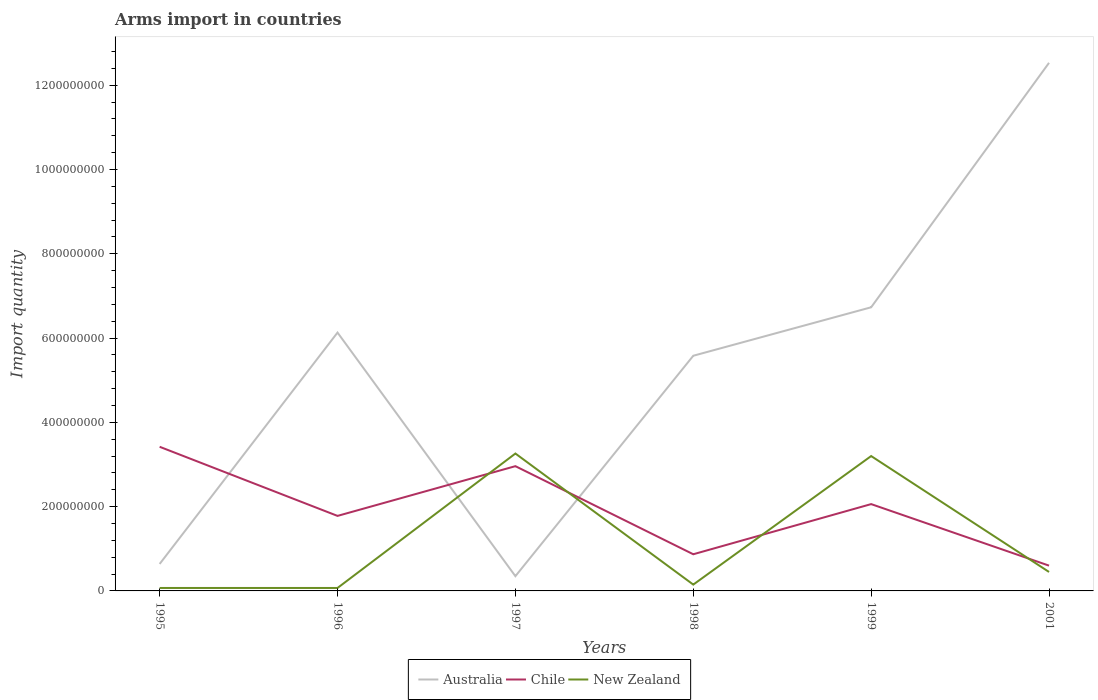How many different coloured lines are there?
Keep it short and to the point. 3. Does the line corresponding to Chile intersect with the line corresponding to New Zealand?
Offer a very short reply. Yes. Across all years, what is the maximum total arms import in Chile?
Make the answer very short. 6.00e+07. In which year was the total arms import in Chile maximum?
Offer a terse response. 2001. What is the total total arms import in Chile in the graph?
Provide a short and direct response. -1.18e+08. What is the difference between the highest and the second highest total arms import in New Zealand?
Make the answer very short. 3.19e+08. Where does the legend appear in the graph?
Make the answer very short. Bottom center. How many legend labels are there?
Give a very brief answer. 3. What is the title of the graph?
Make the answer very short. Arms import in countries. What is the label or title of the Y-axis?
Offer a terse response. Import quantity. What is the Import quantity of Australia in 1995?
Offer a very short reply. 6.40e+07. What is the Import quantity of Chile in 1995?
Provide a succinct answer. 3.42e+08. What is the Import quantity of New Zealand in 1995?
Give a very brief answer. 7.00e+06. What is the Import quantity in Australia in 1996?
Give a very brief answer. 6.13e+08. What is the Import quantity of Chile in 1996?
Your answer should be compact. 1.78e+08. What is the Import quantity of Australia in 1997?
Keep it short and to the point. 3.50e+07. What is the Import quantity in Chile in 1997?
Offer a terse response. 2.96e+08. What is the Import quantity of New Zealand in 1997?
Offer a very short reply. 3.26e+08. What is the Import quantity in Australia in 1998?
Your answer should be compact. 5.58e+08. What is the Import quantity in Chile in 1998?
Keep it short and to the point. 8.70e+07. What is the Import quantity of New Zealand in 1998?
Keep it short and to the point. 1.50e+07. What is the Import quantity in Australia in 1999?
Provide a short and direct response. 6.73e+08. What is the Import quantity of Chile in 1999?
Provide a succinct answer. 2.06e+08. What is the Import quantity of New Zealand in 1999?
Offer a very short reply. 3.20e+08. What is the Import quantity in Australia in 2001?
Provide a short and direct response. 1.25e+09. What is the Import quantity of Chile in 2001?
Provide a succinct answer. 6.00e+07. What is the Import quantity of New Zealand in 2001?
Offer a very short reply. 4.50e+07. Across all years, what is the maximum Import quantity in Australia?
Keep it short and to the point. 1.25e+09. Across all years, what is the maximum Import quantity in Chile?
Give a very brief answer. 3.42e+08. Across all years, what is the maximum Import quantity in New Zealand?
Offer a terse response. 3.26e+08. Across all years, what is the minimum Import quantity in Australia?
Make the answer very short. 3.50e+07. Across all years, what is the minimum Import quantity of Chile?
Give a very brief answer. 6.00e+07. Across all years, what is the minimum Import quantity of New Zealand?
Provide a succinct answer. 7.00e+06. What is the total Import quantity in Australia in the graph?
Keep it short and to the point. 3.20e+09. What is the total Import quantity in Chile in the graph?
Provide a succinct answer. 1.17e+09. What is the total Import quantity in New Zealand in the graph?
Make the answer very short. 7.20e+08. What is the difference between the Import quantity of Australia in 1995 and that in 1996?
Offer a terse response. -5.49e+08. What is the difference between the Import quantity of Chile in 1995 and that in 1996?
Provide a short and direct response. 1.64e+08. What is the difference between the Import quantity in Australia in 1995 and that in 1997?
Make the answer very short. 2.90e+07. What is the difference between the Import quantity of Chile in 1995 and that in 1997?
Keep it short and to the point. 4.60e+07. What is the difference between the Import quantity of New Zealand in 1995 and that in 1997?
Give a very brief answer. -3.19e+08. What is the difference between the Import quantity of Australia in 1995 and that in 1998?
Offer a terse response. -4.94e+08. What is the difference between the Import quantity of Chile in 1995 and that in 1998?
Offer a very short reply. 2.55e+08. What is the difference between the Import quantity of New Zealand in 1995 and that in 1998?
Offer a terse response. -8.00e+06. What is the difference between the Import quantity of Australia in 1995 and that in 1999?
Provide a short and direct response. -6.09e+08. What is the difference between the Import quantity in Chile in 1995 and that in 1999?
Provide a succinct answer. 1.36e+08. What is the difference between the Import quantity in New Zealand in 1995 and that in 1999?
Offer a very short reply. -3.13e+08. What is the difference between the Import quantity of Australia in 1995 and that in 2001?
Keep it short and to the point. -1.19e+09. What is the difference between the Import quantity in Chile in 1995 and that in 2001?
Provide a succinct answer. 2.82e+08. What is the difference between the Import quantity of New Zealand in 1995 and that in 2001?
Your response must be concise. -3.80e+07. What is the difference between the Import quantity of Australia in 1996 and that in 1997?
Make the answer very short. 5.78e+08. What is the difference between the Import quantity in Chile in 1996 and that in 1997?
Your answer should be very brief. -1.18e+08. What is the difference between the Import quantity of New Zealand in 1996 and that in 1997?
Make the answer very short. -3.19e+08. What is the difference between the Import quantity in Australia in 1996 and that in 1998?
Your response must be concise. 5.50e+07. What is the difference between the Import quantity in Chile in 1996 and that in 1998?
Make the answer very short. 9.10e+07. What is the difference between the Import quantity in New Zealand in 1996 and that in 1998?
Your answer should be compact. -8.00e+06. What is the difference between the Import quantity in Australia in 1996 and that in 1999?
Your answer should be compact. -6.00e+07. What is the difference between the Import quantity of Chile in 1996 and that in 1999?
Ensure brevity in your answer.  -2.80e+07. What is the difference between the Import quantity of New Zealand in 1996 and that in 1999?
Your answer should be very brief. -3.13e+08. What is the difference between the Import quantity of Australia in 1996 and that in 2001?
Make the answer very short. -6.40e+08. What is the difference between the Import quantity of Chile in 1996 and that in 2001?
Offer a very short reply. 1.18e+08. What is the difference between the Import quantity of New Zealand in 1996 and that in 2001?
Offer a terse response. -3.80e+07. What is the difference between the Import quantity in Australia in 1997 and that in 1998?
Your answer should be very brief. -5.23e+08. What is the difference between the Import quantity of Chile in 1997 and that in 1998?
Your answer should be compact. 2.09e+08. What is the difference between the Import quantity in New Zealand in 1997 and that in 1998?
Ensure brevity in your answer.  3.11e+08. What is the difference between the Import quantity in Australia in 1997 and that in 1999?
Provide a short and direct response. -6.38e+08. What is the difference between the Import quantity of Chile in 1997 and that in 1999?
Offer a very short reply. 9.00e+07. What is the difference between the Import quantity in New Zealand in 1997 and that in 1999?
Ensure brevity in your answer.  6.00e+06. What is the difference between the Import quantity of Australia in 1997 and that in 2001?
Keep it short and to the point. -1.22e+09. What is the difference between the Import quantity of Chile in 1997 and that in 2001?
Provide a short and direct response. 2.36e+08. What is the difference between the Import quantity in New Zealand in 1997 and that in 2001?
Ensure brevity in your answer.  2.81e+08. What is the difference between the Import quantity in Australia in 1998 and that in 1999?
Provide a succinct answer. -1.15e+08. What is the difference between the Import quantity in Chile in 1998 and that in 1999?
Give a very brief answer. -1.19e+08. What is the difference between the Import quantity of New Zealand in 1998 and that in 1999?
Provide a succinct answer. -3.05e+08. What is the difference between the Import quantity of Australia in 1998 and that in 2001?
Your answer should be very brief. -6.95e+08. What is the difference between the Import quantity in Chile in 1998 and that in 2001?
Your response must be concise. 2.70e+07. What is the difference between the Import quantity of New Zealand in 1998 and that in 2001?
Provide a succinct answer. -3.00e+07. What is the difference between the Import quantity in Australia in 1999 and that in 2001?
Provide a succinct answer. -5.80e+08. What is the difference between the Import quantity in Chile in 1999 and that in 2001?
Give a very brief answer. 1.46e+08. What is the difference between the Import quantity of New Zealand in 1999 and that in 2001?
Ensure brevity in your answer.  2.75e+08. What is the difference between the Import quantity in Australia in 1995 and the Import quantity in Chile in 1996?
Your answer should be very brief. -1.14e+08. What is the difference between the Import quantity of Australia in 1995 and the Import quantity of New Zealand in 1996?
Your response must be concise. 5.70e+07. What is the difference between the Import quantity of Chile in 1995 and the Import quantity of New Zealand in 1996?
Give a very brief answer. 3.35e+08. What is the difference between the Import quantity in Australia in 1995 and the Import quantity in Chile in 1997?
Provide a succinct answer. -2.32e+08. What is the difference between the Import quantity of Australia in 1995 and the Import quantity of New Zealand in 1997?
Provide a succinct answer. -2.62e+08. What is the difference between the Import quantity of Chile in 1995 and the Import quantity of New Zealand in 1997?
Your answer should be compact. 1.60e+07. What is the difference between the Import quantity of Australia in 1995 and the Import quantity of Chile in 1998?
Your response must be concise. -2.30e+07. What is the difference between the Import quantity in Australia in 1995 and the Import quantity in New Zealand in 1998?
Offer a very short reply. 4.90e+07. What is the difference between the Import quantity of Chile in 1995 and the Import quantity of New Zealand in 1998?
Make the answer very short. 3.27e+08. What is the difference between the Import quantity in Australia in 1995 and the Import quantity in Chile in 1999?
Offer a very short reply. -1.42e+08. What is the difference between the Import quantity of Australia in 1995 and the Import quantity of New Zealand in 1999?
Make the answer very short. -2.56e+08. What is the difference between the Import quantity of Chile in 1995 and the Import quantity of New Zealand in 1999?
Your answer should be very brief. 2.20e+07. What is the difference between the Import quantity in Australia in 1995 and the Import quantity in New Zealand in 2001?
Your answer should be very brief. 1.90e+07. What is the difference between the Import quantity in Chile in 1995 and the Import quantity in New Zealand in 2001?
Your answer should be very brief. 2.97e+08. What is the difference between the Import quantity of Australia in 1996 and the Import quantity of Chile in 1997?
Give a very brief answer. 3.17e+08. What is the difference between the Import quantity of Australia in 1996 and the Import quantity of New Zealand in 1997?
Keep it short and to the point. 2.87e+08. What is the difference between the Import quantity in Chile in 1996 and the Import quantity in New Zealand in 1997?
Make the answer very short. -1.48e+08. What is the difference between the Import quantity of Australia in 1996 and the Import quantity of Chile in 1998?
Offer a terse response. 5.26e+08. What is the difference between the Import quantity of Australia in 1996 and the Import quantity of New Zealand in 1998?
Your answer should be compact. 5.98e+08. What is the difference between the Import quantity in Chile in 1996 and the Import quantity in New Zealand in 1998?
Provide a short and direct response. 1.63e+08. What is the difference between the Import quantity in Australia in 1996 and the Import quantity in Chile in 1999?
Give a very brief answer. 4.07e+08. What is the difference between the Import quantity in Australia in 1996 and the Import quantity in New Zealand in 1999?
Provide a short and direct response. 2.93e+08. What is the difference between the Import quantity of Chile in 1996 and the Import quantity of New Zealand in 1999?
Make the answer very short. -1.42e+08. What is the difference between the Import quantity in Australia in 1996 and the Import quantity in Chile in 2001?
Give a very brief answer. 5.53e+08. What is the difference between the Import quantity of Australia in 1996 and the Import quantity of New Zealand in 2001?
Make the answer very short. 5.68e+08. What is the difference between the Import quantity of Chile in 1996 and the Import quantity of New Zealand in 2001?
Ensure brevity in your answer.  1.33e+08. What is the difference between the Import quantity of Australia in 1997 and the Import quantity of Chile in 1998?
Your response must be concise. -5.20e+07. What is the difference between the Import quantity of Chile in 1997 and the Import quantity of New Zealand in 1998?
Provide a short and direct response. 2.81e+08. What is the difference between the Import quantity of Australia in 1997 and the Import quantity of Chile in 1999?
Your response must be concise. -1.71e+08. What is the difference between the Import quantity of Australia in 1997 and the Import quantity of New Zealand in 1999?
Give a very brief answer. -2.85e+08. What is the difference between the Import quantity in Chile in 1997 and the Import quantity in New Zealand in 1999?
Give a very brief answer. -2.40e+07. What is the difference between the Import quantity in Australia in 1997 and the Import quantity in Chile in 2001?
Provide a short and direct response. -2.50e+07. What is the difference between the Import quantity in Australia in 1997 and the Import quantity in New Zealand in 2001?
Offer a terse response. -1.00e+07. What is the difference between the Import quantity of Chile in 1997 and the Import quantity of New Zealand in 2001?
Offer a terse response. 2.51e+08. What is the difference between the Import quantity in Australia in 1998 and the Import quantity in Chile in 1999?
Offer a very short reply. 3.52e+08. What is the difference between the Import quantity of Australia in 1998 and the Import quantity of New Zealand in 1999?
Provide a succinct answer. 2.38e+08. What is the difference between the Import quantity of Chile in 1998 and the Import quantity of New Zealand in 1999?
Provide a succinct answer. -2.33e+08. What is the difference between the Import quantity of Australia in 1998 and the Import quantity of Chile in 2001?
Offer a terse response. 4.98e+08. What is the difference between the Import quantity of Australia in 1998 and the Import quantity of New Zealand in 2001?
Keep it short and to the point. 5.13e+08. What is the difference between the Import quantity in Chile in 1998 and the Import quantity in New Zealand in 2001?
Make the answer very short. 4.20e+07. What is the difference between the Import quantity of Australia in 1999 and the Import quantity of Chile in 2001?
Your response must be concise. 6.13e+08. What is the difference between the Import quantity in Australia in 1999 and the Import quantity in New Zealand in 2001?
Make the answer very short. 6.28e+08. What is the difference between the Import quantity of Chile in 1999 and the Import quantity of New Zealand in 2001?
Your answer should be compact. 1.61e+08. What is the average Import quantity of Australia per year?
Your answer should be very brief. 5.33e+08. What is the average Import quantity of Chile per year?
Make the answer very short. 1.95e+08. What is the average Import quantity in New Zealand per year?
Offer a very short reply. 1.20e+08. In the year 1995, what is the difference between the Import quantity in Australia and Import quantity in Chile?
Make the answer very short. -2.78e+08. In the year 1995, what is the difference between the Import quantity of Australia and Import quantity of New Zealand?
Your response must be concise. 5.70e+07. In the year 1995, what is the difference between the Import quantity in Chile and Import quantity in New Zealand?
Offer a terse response. 3.35e+08. In the year 1996, what is the difference between the Import quantity in Australia and Import quantity in Chile?
Offer a terse response. 4.35e+08. In the year 1996, what is the difference between the Import quantity in Australia and Import quantity in New Zealand?
Offer a very short reply. 6.06e+08. In the year 1996, what is the difference between the Import quantity of Chile and Import quantity of New Zealand?
Offer a very short reply. 1.71e+08. In the year 1997, what is the difference between the Import quantity of Australia and Import quantity of Chile?
Give a very brief answer. -2.61e+08. In the year 1997, what is the difference between the Import quantity in Australia and Import quantity in New Zealand?
Offer a very short reply. -2.91e+08. In the year 1997, what is the difference between the Import quantity of Chile and Import quantity of New Zealand?
Provide a succinct answer. -3.00e+07. In the year 1998, what is the difference between the Import quantity in Australia and Import quantity in Chile?
Offer a terse response. 4.71e+08. In the year 1998, what is the difference between the Import quantity in Australia and Import quantity in New Zealand?
Provide a short and direct response. 5.43e+08. In the year 1998, what is the difference between the Import quantity of Chile and Import quantity of New Zealand?
Your response must be concise. 7.20e+07. In the year 1999, what is the difference between the Import quantity of Australia and Import quantity of Chile?
Make the answer very short. 4.67e+08. In the year 1999, what is the difference between the Import quantity in Australia and Import quantity in New Zealand?
Make the answer very short. 3.53e+08. In the year 1999, what is the difference between the Import quantity of Chile and Import quantity of New Zealand?
Make the answer very short. -1.14e+08. In the year 2001, what is the difference between the Import quantity in Australia and Import quantity in Chile?
Provide a succinct answer. 1.19e+09. In the year 2001, what is the difference between the Import quantity of Australia and Import quantity of New Zealand?
Provide a short and direct response. 1.21e+09. In the year 2001, what is the difference between the Import quantity of Chile and Import quantity of New Zealand?
Your answer should be compact. 1.50e+07. What is the ratio of the Import quantity in Australia in 1995 to that in 1996?
Provide a succinct answer. 0.1. What is the ratio of the Import quantity of Chile in 1995 to that in 1996?
Keep it short and to the point. 1.92. What is the ratio of the Import quantity in Australia in 1995 to that in 1997?
Provide a short and direct response. 1.83. What is the ratio of the Import quantity of Chile in 1995 to that in 1997?
Keep it short and to the point. 1.16. What is the ratio of the Import quantity of New Zealand in 1995 to that in 1997?
Your response must be concise. 0.02. What is the ratio of the Import quantity of Australia in 1995 to that in 1998?
Your answer should be very brief. 0.11. What is the ratio of the Import quantity of Chile in 1995 to that in 1998?
Your answer should be very brief. 3.93. What is the ratio of the Import quantity of New Zealand in 1995 to that in 1998?
Your answer should be compact. 0.47. What is the ratio of the Import quantity in Australia in 1995 to that in 1999?
Offer a very short reply. 0.1. What is the ratio of the Import quantity of Chile in 1995 to that in 1999?
Provide a succinct answer. 1.66. What is the ratio of the Import quantity of New Zealand in 1995 to that in 1999?
Offer a very short reply. 0.02. What is the ratio of the Import quantity in Australia in 1995 to that in 2001?
Offer a very short reply. 0.05. What is the ratio of the Import quantity of New Zealand in 1995 to that in 2001?
Your answer should be very brief. 0.16. What is the ratio of the Import quantity of Australia in 1996 to that in 1997?
Your answer should be very brief. 17.51. What is the ratio of the Import quantity in Chile in 1996 to that in 1997?
Your response must be concise. 0.6. What is the ratio of the Import quantity of New Zealand in 1996 to that in 1997?
Provide a short and direct response. 0.02. What is the ratio of the Import quantity in Australia in 1996 to that in 1998?
Offer a terse response. 1.1. What is the ratio of the Import quantity of Chile in 1996 to that in 1998?
Your answer should be very brief. 2.05. What is the ratio of the Import quantity in New Zealand in 1996 to that in 1998?
Your answer should be very brief. 0.47. What is the ratio of the Import quantity in Australia in 1996 to that in 1999?
Offer a very short reply. 0.91. What is the ratio of the Import quantity of Chile in 1996 to that in 1999?
Give a very brief answer. 0.86. What is the ratio of the Import quantity in New Zealand in 1996 to that in 1999?
Offer a very short reply. 0.02. What is the ratio of the Import quantity in Australia in 1996 to that in 2001?
Offer a very short reply. 0.49. What is the ratio of the Import quantity of Chile in 1996 to that in 2001?
Your response must be concise. 2.97. What is the ratio of the Import quantity in New Zealand in 1996 to that in 2001?
Provide a succinct answer. 0.16. What is the ratio of the Import quantity in Australia in 1997 to that in 1998?
Provide a succinct answer. 0.06. What is the ratio of the Import quantity of Chile in 1997 to that in 1998?
Make the answer very short. 3.4. What is the ratio of the Import quantity in New Zealand in 1997 to that in 1998?
Your response must be concise. 21.73. What is the ratio of the Import quantity in Australia in 1997 to that in 1999?
Give a very brief answer. 0.05. What is the ratio of the Import quantity of Chile in 1997 to that in 1999?
Your response must be concise. 1.44. What is the ratio of the Import quantity in New Zealand in 1997 to that in 1999?
Provide a short and direct response. 1.02. What is the ratio of the Import quantity of Australia in 1997 to that in 2001?
Your answer should be very brief. 0.03. What is the ratio of the Import quantity of Chile in 1997 to that in 2001?
Provide a short and direct response. 4.93. What is the ratio of the Import quantity of New Zealand in 1997 to that in 2001?
Keep it short and to the point. 7.24. What is the ratio of the Import quantity in Australia in 1998 to that in 1999?
Provide a short and direct response. 0.83. What is the ratio of the Import quantity of Chile in 1998 to that in 1999?
Your answer should be very brief. 0.42. What is the ratio of the Import quantity in New Zealand in 1998 to that in 1999?
Give a very brief answer. 0.05. What is the ratio of the Import quantity of Australia in 1998 to that in 2001?
Your response must be concise. 0.45. What is the ratio of the Import quantity in Chile in 1998 to that in 2001?
Offer a very short reply. 1.45. What is the ratio of the Import quantity of New Zealand in 1998 to that in 2001?
Provide a short and direct response. 0.33. What is the ratio of the Import quantity in Australia in 1999 to that in 2001?
Keep it short and to the point. 0.54. What is the ratio of the Import quantity of Chile in 1999 to that in 2001?
Give a very brief answer. 3.43. What is the ratio of the Import quantity in New Zealand in 1999 to that in 2001?
Ensure brevity in your answer.  7.11. What is the difference between the highest and the second highest Import quantity of Australia?
Keep it short and to the point. 5.80e+08. What is the difference between the highest and the second highest Import quantity of Chile?
Your answer should be very brief. 4.60e+07. What is the difference between the highest and the second highest Import quantity of New Zealand?
Provide a succinct answer. 6.00e+06. What is the difference between the highest and the lowest Import quantity in Australia?
Offer a very short reply. 1.22e+09. What is the difference between the highest and the lowest Import quantity in Chile?
Give a very brief answer. 2.82e+08. What is the difference between the highest and the lowest Import quantity in New Zealand?
Provide a short and direct response. 3.19e+08. 